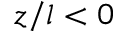Convert formula to latex. <formula><loc_0><loc_0><loc_500><loc_500>z / l < 0</formula> 